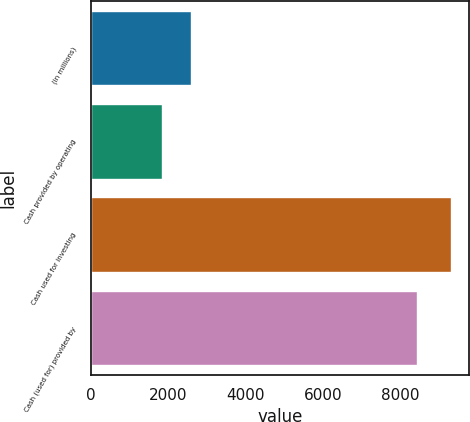Convert chart. <chart><loc_0><loc_0><loc_500><loc_500><bar_chart><fcel>(in millions)<fcel>Cash provided by operating<fcel>Cash used for investing<fcel>Cash (used for) provided by<nl><fcel>2591.7<fcel>1845<fcel>9312<fcel>8439<nl></chart> 